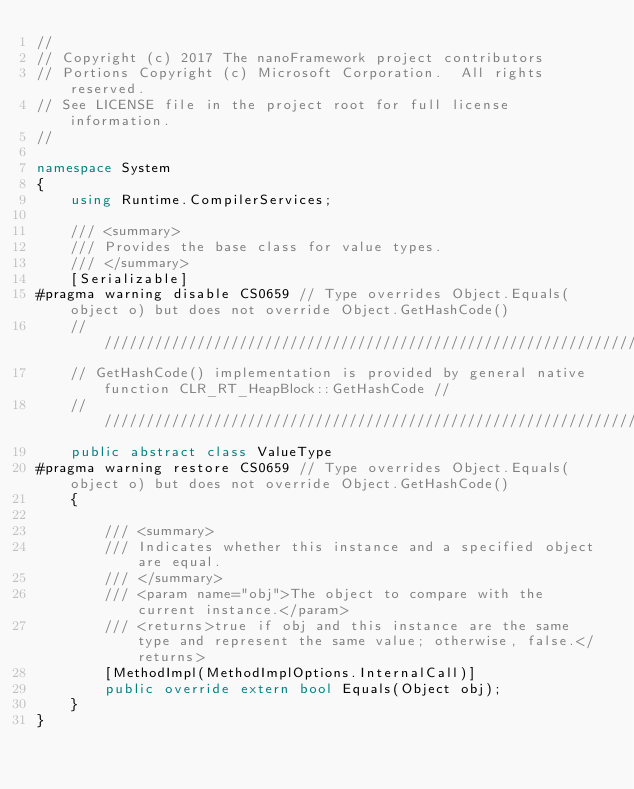<code> <loc_0><loc_0><loc_500><loc_500><_C#_>//
// Copyright (c) 2017 The nanoFramework project contributors
// Portions Copyright (c) Microsoft Corporation.  All rights reserved.
// See LICENSE file in the project root for full license information.
//

namespace System
{
    using Runtime.CompilerServices;

    /// <summary>
    /// Provides the base class for value types.
    /// </summary>
    [Serializable]
#pragma warning disable CS0659 // Type overrides Object.Equals(object o) but does not override Object.GetHashCode()
    ///////////////////////////////////////////////////////////////////////////////////////////////////////
    // GetHashCode() implementation is provided by general native function CLR_RT_HeapBlock::GetHashCode //
    ///////////////////////////////////////////////////////////////////////////////////////////////////////
    public abstract class ValueType
#pragma warning restore CS0659 // Type overrides Object.Equals(object o) but does not override Object.GetHashCode()
    {

        /// <summary>
        /// Indicates whether this instance and a specified object are equal.
        /// </summary>
        /// <param name="obj">The object to compare with the current instance.</param>
        /// <returns>true if obj and this instance are the same type and represent the same value; otherwise, false.</returns>
        [MethodImpl(MethodImplOptions.InternalCall)]
        public override extern bool Equals(Object obj);
    }
}
</code> 